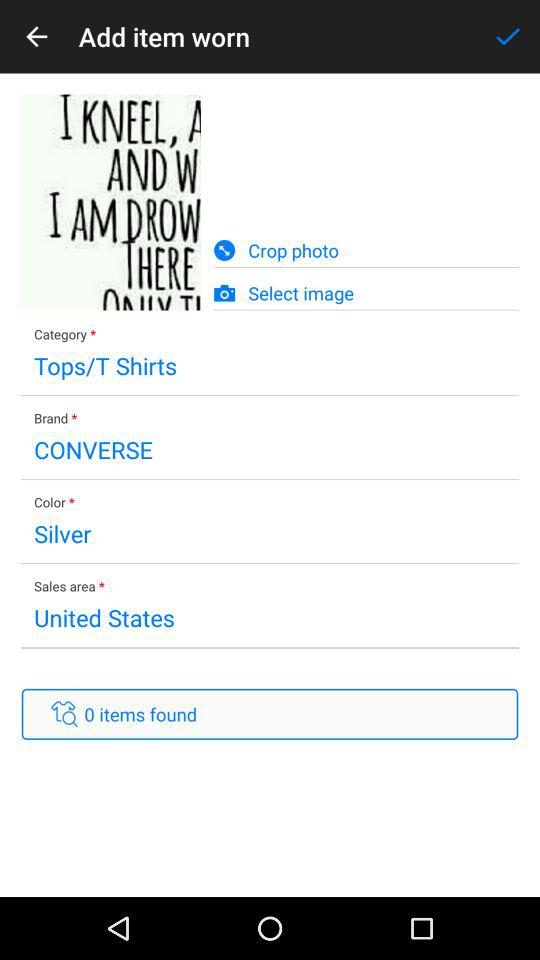What is the brand? The brand is "CONVERSE". 